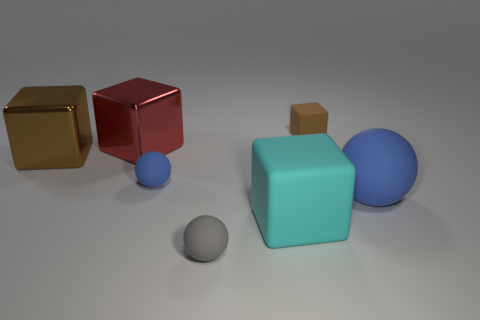Is there a rubber object of the same size as the gray rubber sphere?
Your answer should be compact. Yes. What color is the large matte block?
Keep it short and to the point. Cyan. What color is the sphere in front of the big matte thing that is on the left side of the big blue matte ball?
Provide a short and direct response. Gray. The object that is behind the metallic thing that is behind the brown thing that is on the left side of the tiny blue sphere is what shape?
Your answer should be very brief. Cube. How many other blocks have the same material as the small cube?
Your answer should be very brief. 1. How many matte things are behind the blue matte object to the left of the cyan block?
Make the answer very short. 1. How many big brown balls are there?
Offer a very short reply. 0. Is the red cube made of the same material as the ball that is right of the big cyan rubber cube?
Offer a very short reply. No. Is the color of the big matte object to the right of the small cube the same as the small rubber block?
Make the answer very short. No. What is the block that is both behind the large brown metal thing and in front of the brown matte thing made of?
Ensure brevity in your answer.  Metal. 